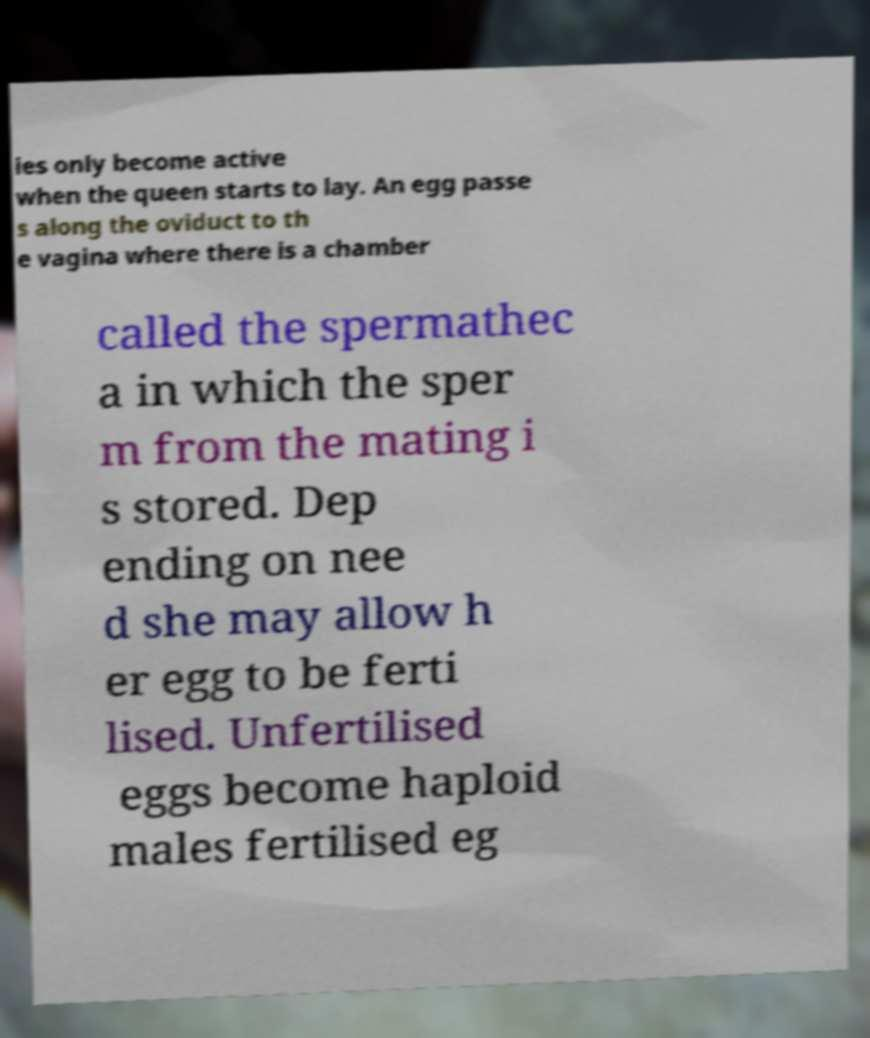Can you read and provide the text displayed in the image?This photo seems to have some interesting text. Can you extract and type it out for me? ies only become active when the queen starts to lay. An egg passe s along the oviduct to th e vagina where there is a chamber called the spermathec a in which the sper m from the mating i s stored. Dep ending on nee d she may allow h er egg to be ferti lised. Unfertilised eggs become haploid males fertilised eg 